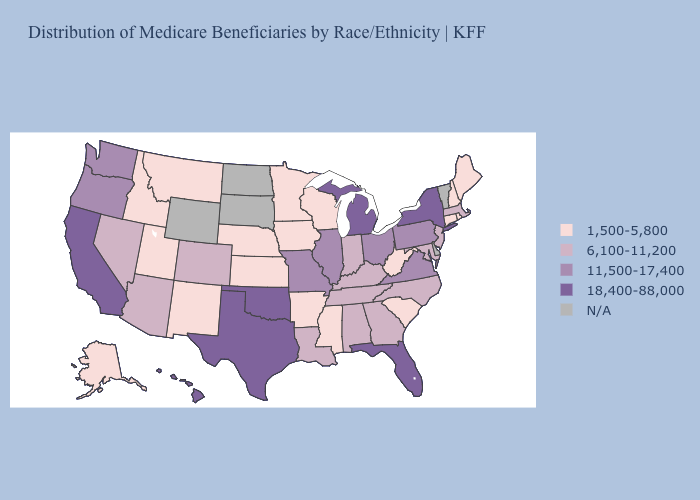Which states hav the highest value in the MidWest?
Write a very short answer. Michigan. Name the states that have a value in the range N/A?
Short answer required. Delaware, North Dakota, South Dakota, Vermont, Wyoming. Does the map have missing data?
Concise answer only. Yes. What is the lowest value in states that border New Hampshire?
Concise answer only. 1,500-5,800. What is the value of Louisiana?
Write a very short answer. 6,100-11,200. Name the states that have a value in the range N/A?
Quick response, please. Delaware, North Dakota, South Dakota, Vermont, Wyoming. Does New Hampshire have the lowest value in the Northeast?
Answer briefly. Yes. What is the value of Iowa?
Answer briefly. 1,500-5,800. Does Iowa have the lowest value in the MidWest?
Give a very brief answer. Yes. What is the value of Kansas?
Write a very short answer. 1,500-5,800. Name the states that have a value in the range 6,100-11,200?
Quick response, please. Alabama, Arizona, Colorado, Georgia, Indiana, Kentucky, Louisiana, Maryland, Massachusetts, Nevada, New Jersey, North Carolina, Tennessee. 